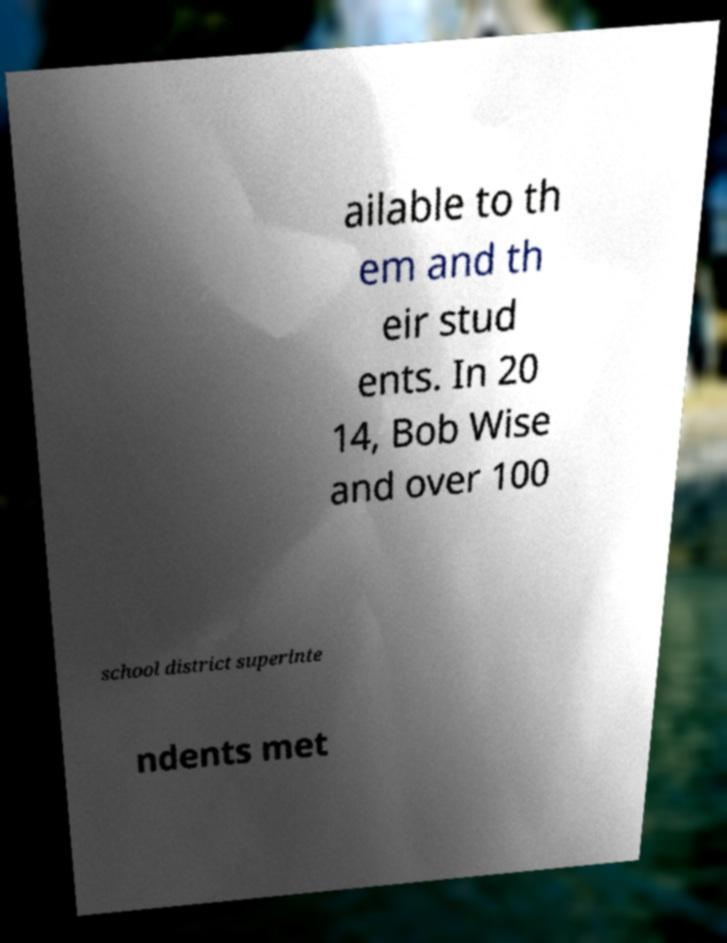For documentation purposes, I need the text within this image transcribed. Could you provide that? ailable to th em and th eir stud ents. In 20 14, Bob Wise and over 100 school district superinte ndents met 